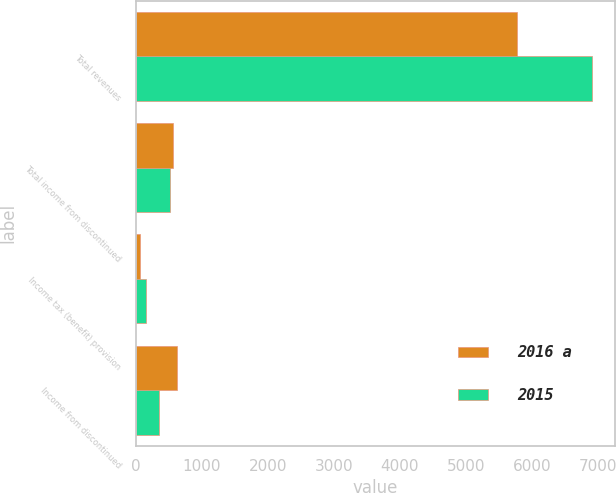Convert chart to OTSL. <chart><loc_0><loc_0><loc_500><loc_500><stacked_bar_chart><ecel><fcel>Total revenues<fcel>Total income from discontinued<fcel>Income tax (benefit) provision<fcel>Income from discontinued<nl><fcel>2016 a<fcel>5776<fcel>571<fcel>65<fcel>625<nl><fcel>2015<fcel>6909<fcel>526<fcel>164<fcel>357<nl></chart> 